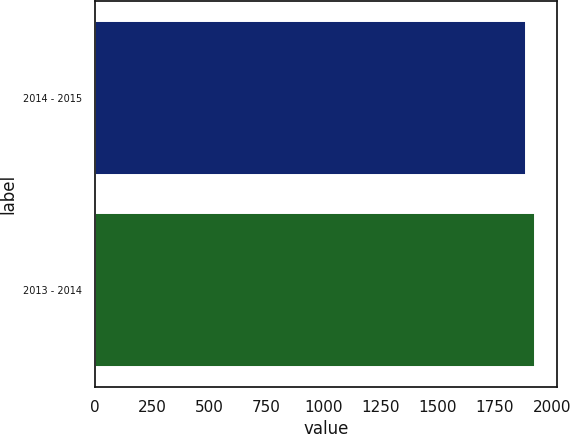Convert chart. <chart><loc_0><loc_0><loc_500><loc_500><bar_chart><fcel>2014 - 2015<fcel>2013 - 2014<nl><fcel>1885<fcel>1928.1<nl></chart> 